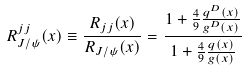<formula> <loc_0><loc_0><loc_500><loc_500>R ^ { j j } _ { J / \psi } ( x ) \equiv \frac { R _ { j j } ( x ) } { R _ { J / \psi } ( x ) } = \frac { 1 + \frac { 4 } { 9 } \frac { q ^ { D } ( x ) } { g ^ { D } ( x ) } } { 1 + \frac { 4 } { 9 } \frac { q ( x ) } { g ( x ) } }</formula> 